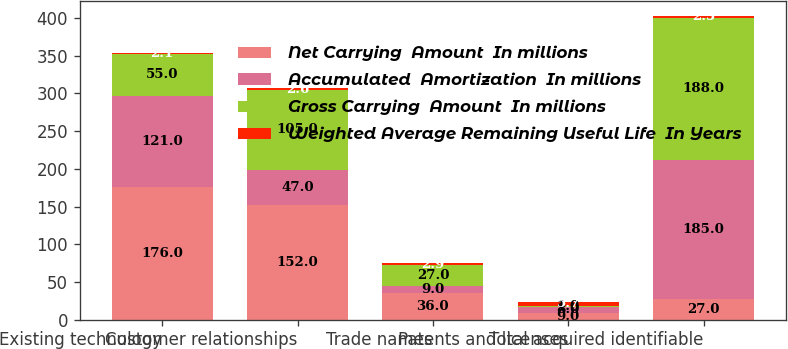<chart> <loc_0><loc_0><loc_500><loc_500><stacked_bar_chart><ecel><fcel>Existing technology<fcel>Customer relationships<fcel>Trade names<fcel>Patents and licenses<fcel>Total acquired identifiable<nl><fcel>Net Carrying  Amount  In millions<fcel>176<fcel>152<fcel>36<fcel>9<fcel>27<nl><fcel>Accumulated  Amortization  In millions<fcel>121<fcel>47<fcel>9<fcel>8<fcel>185<nl><fcel>Gross Carrying  Amount  In millions<fcel>55<fcel>105<fcel>27<fcel>1<fcel>188<nl><fcel>Weighted Average Remaining Useful Life  In Years<fcel>2.1<fcel>2.6<fcel>2.9<fcel>5.7<fcel>2.5<nl></chart> 